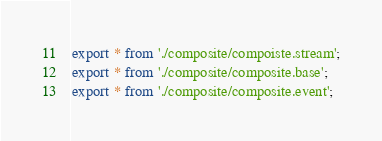<code> <loc_0><loc_0><loc_500><loc_500><_TypeScript_>export * from './composite/compoiste.stream';
export * from './composite/composite.base';
export * from './composite/composite.event';
</code> 